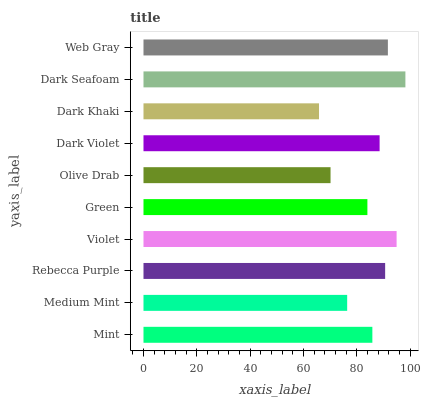Is Dark Khaki the minimum?
Answer yes or no. Yes. Is Dark Seafoam the maximum?
Answer yes or no. Yes. Is Medium Mint the minimum?
Answer yes or no. No. Is Medium Mint the maximum?
Answer yes or no. No. Is Mint greater than Medium Mint?
Answer yes or no. Yes. Is Medium Mint less than Mint?
Answer yes or no. Yes. Is Medium Mint greater than Mint?
Answer yes or no. No. Is Mint less than Medium Mint?
Answer yes or no. No. Is Dark Violet the high median?
Answer yes or no. Yes. Is Mint the low median?
Answer yes or no. Yes. Is Rebecca Purple the high median?
Answer yes or no. No. Is Dark Khaki the low median?
Answer yes or no. No. 